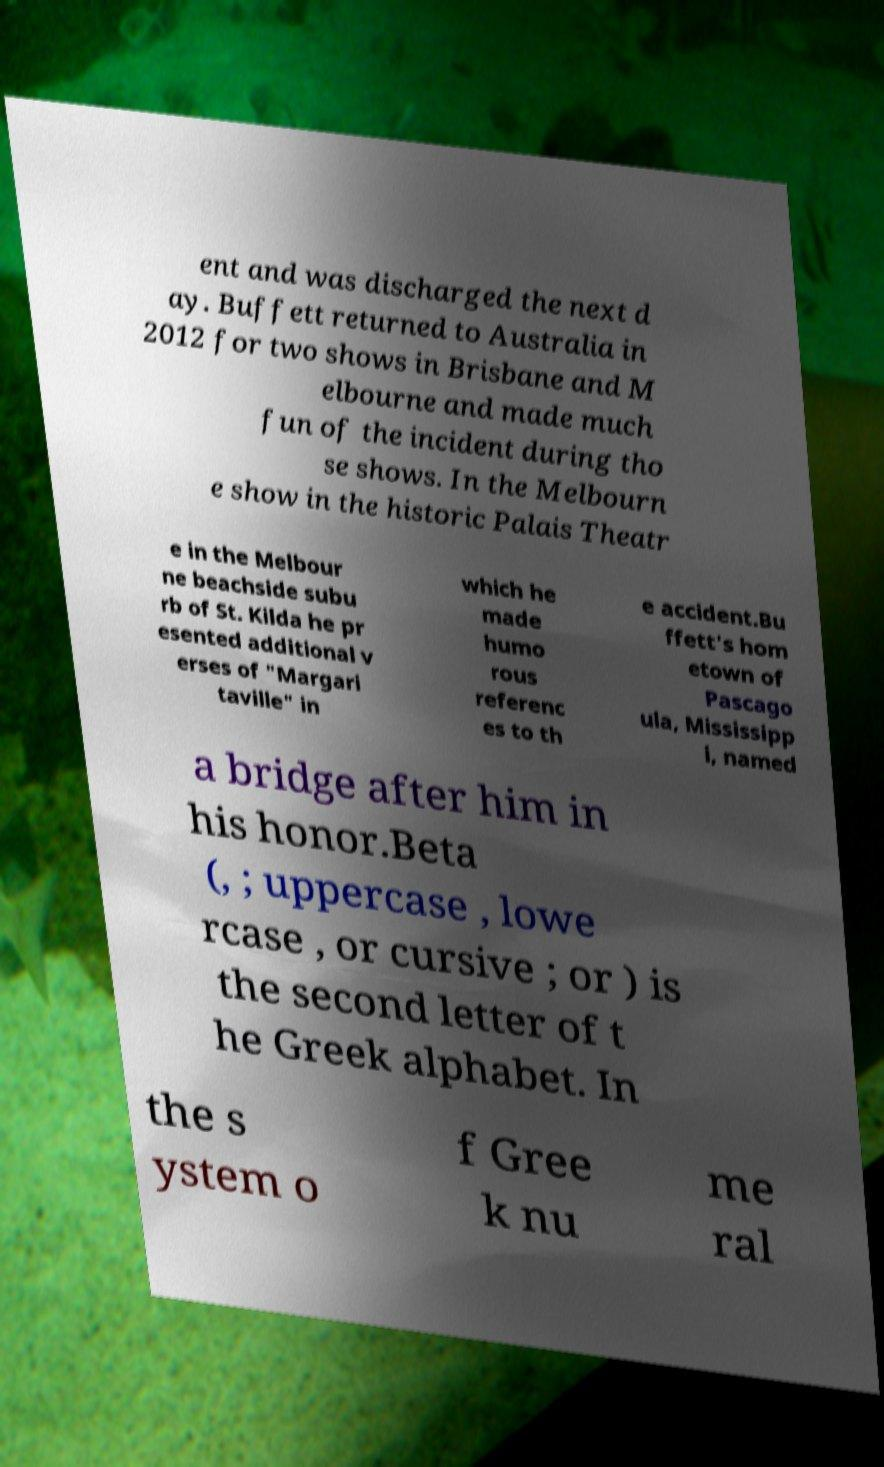Can you accurately transcribe the text from the provided image for me? ent and was discharged the next d ay. Buffett returned to Australia in 2012 for two shows in Brisbane and M elbourne and made much fun of the incident during tho se shows. In the Melbourn e show in the historic Palais Theatr e in the Melbour ne beachside subu rb of St. Kilda he pr esented additional v erses of "Margari taville" in which he made humo rous referenc es to th e accident.Bu ffett's hom etown of Pascago ula, Mississipp i, named a bridge after him in his honor.Beta (, ; uppercase , lowe rcase , or cursive ; or ) is the second letter of t he Greek alphabet. In the s ystem o f Gree k nu me ral 